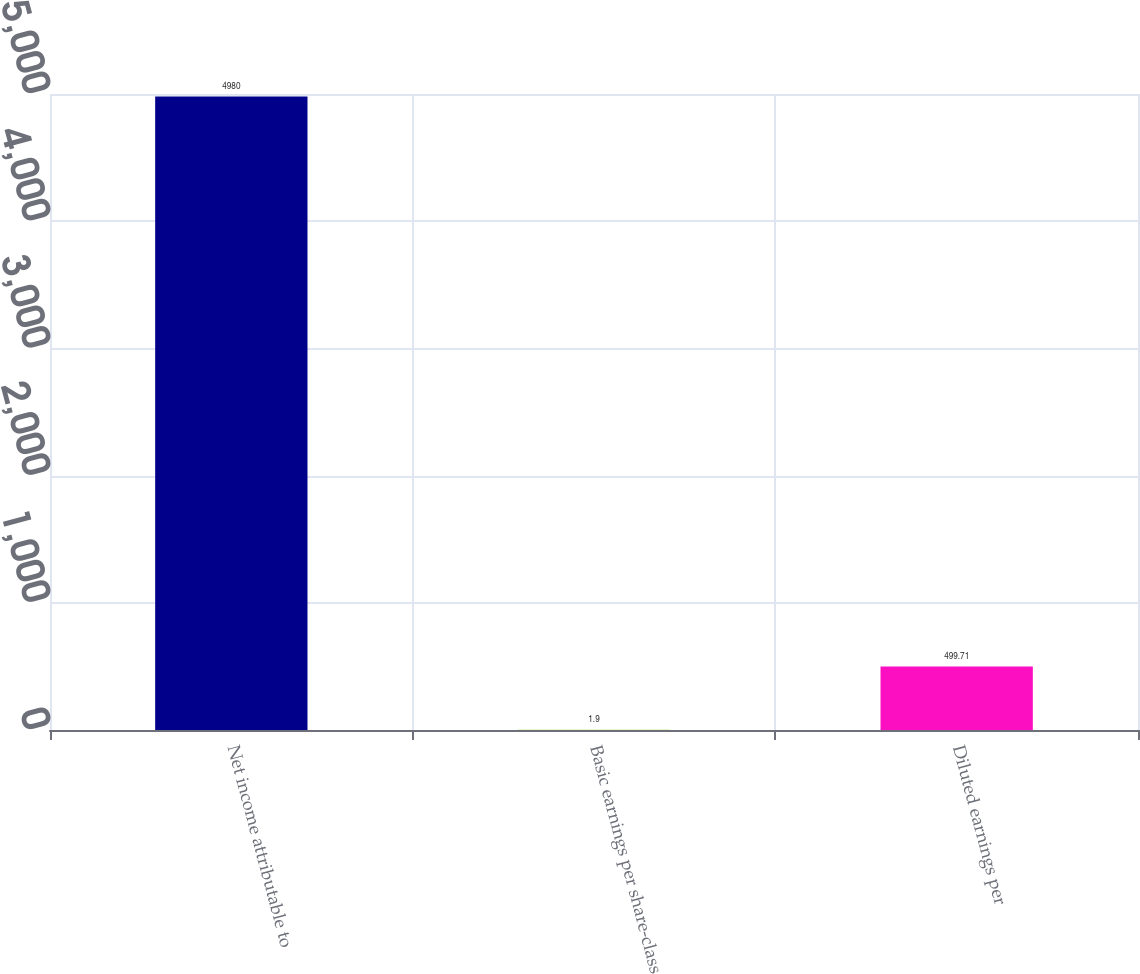Convert chart. <chart><loc_0><loc_0><loc_500><loc_500><bar_chart><fcel>Net income attributable to<fcel>Basic earnings per share-class<fcel>Diluted earnings per<nl><fcel>4980<fcel>1.9<fcel>499.71<nl></chart> 